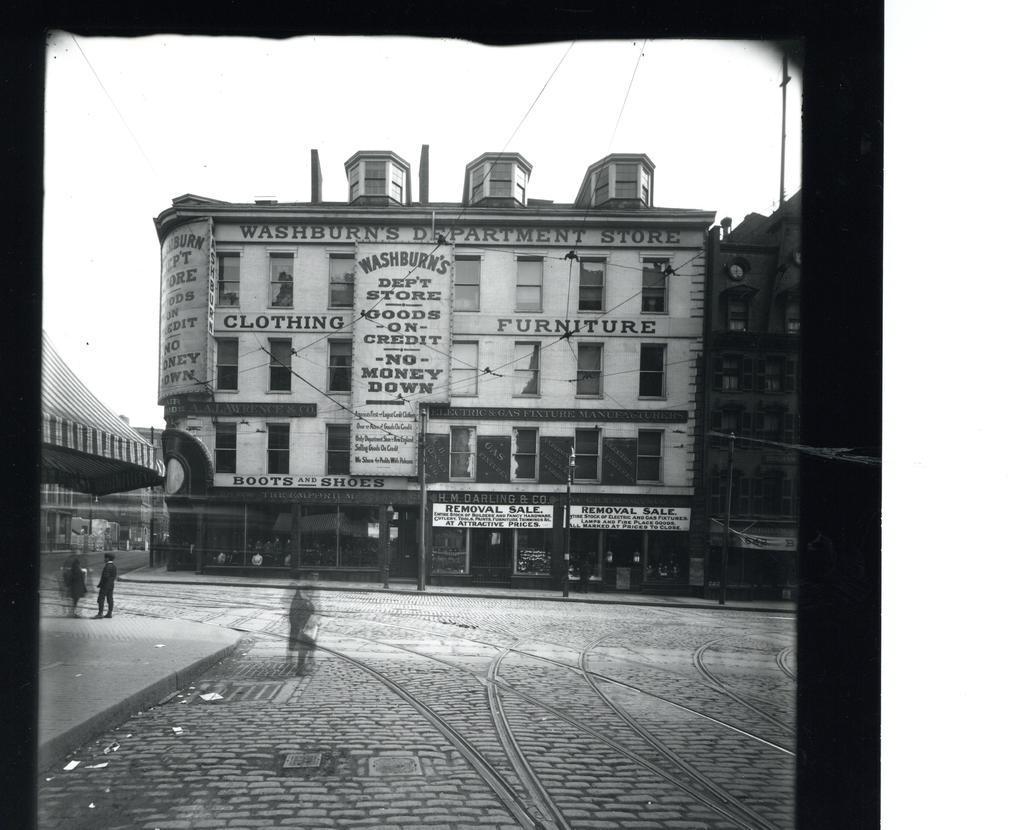Could you give a brief overview of what you see in this image? This is a black and white picture, in this image we can see a few buildings with boards, there are some people, windows and poles, in the background we can see the sky. 